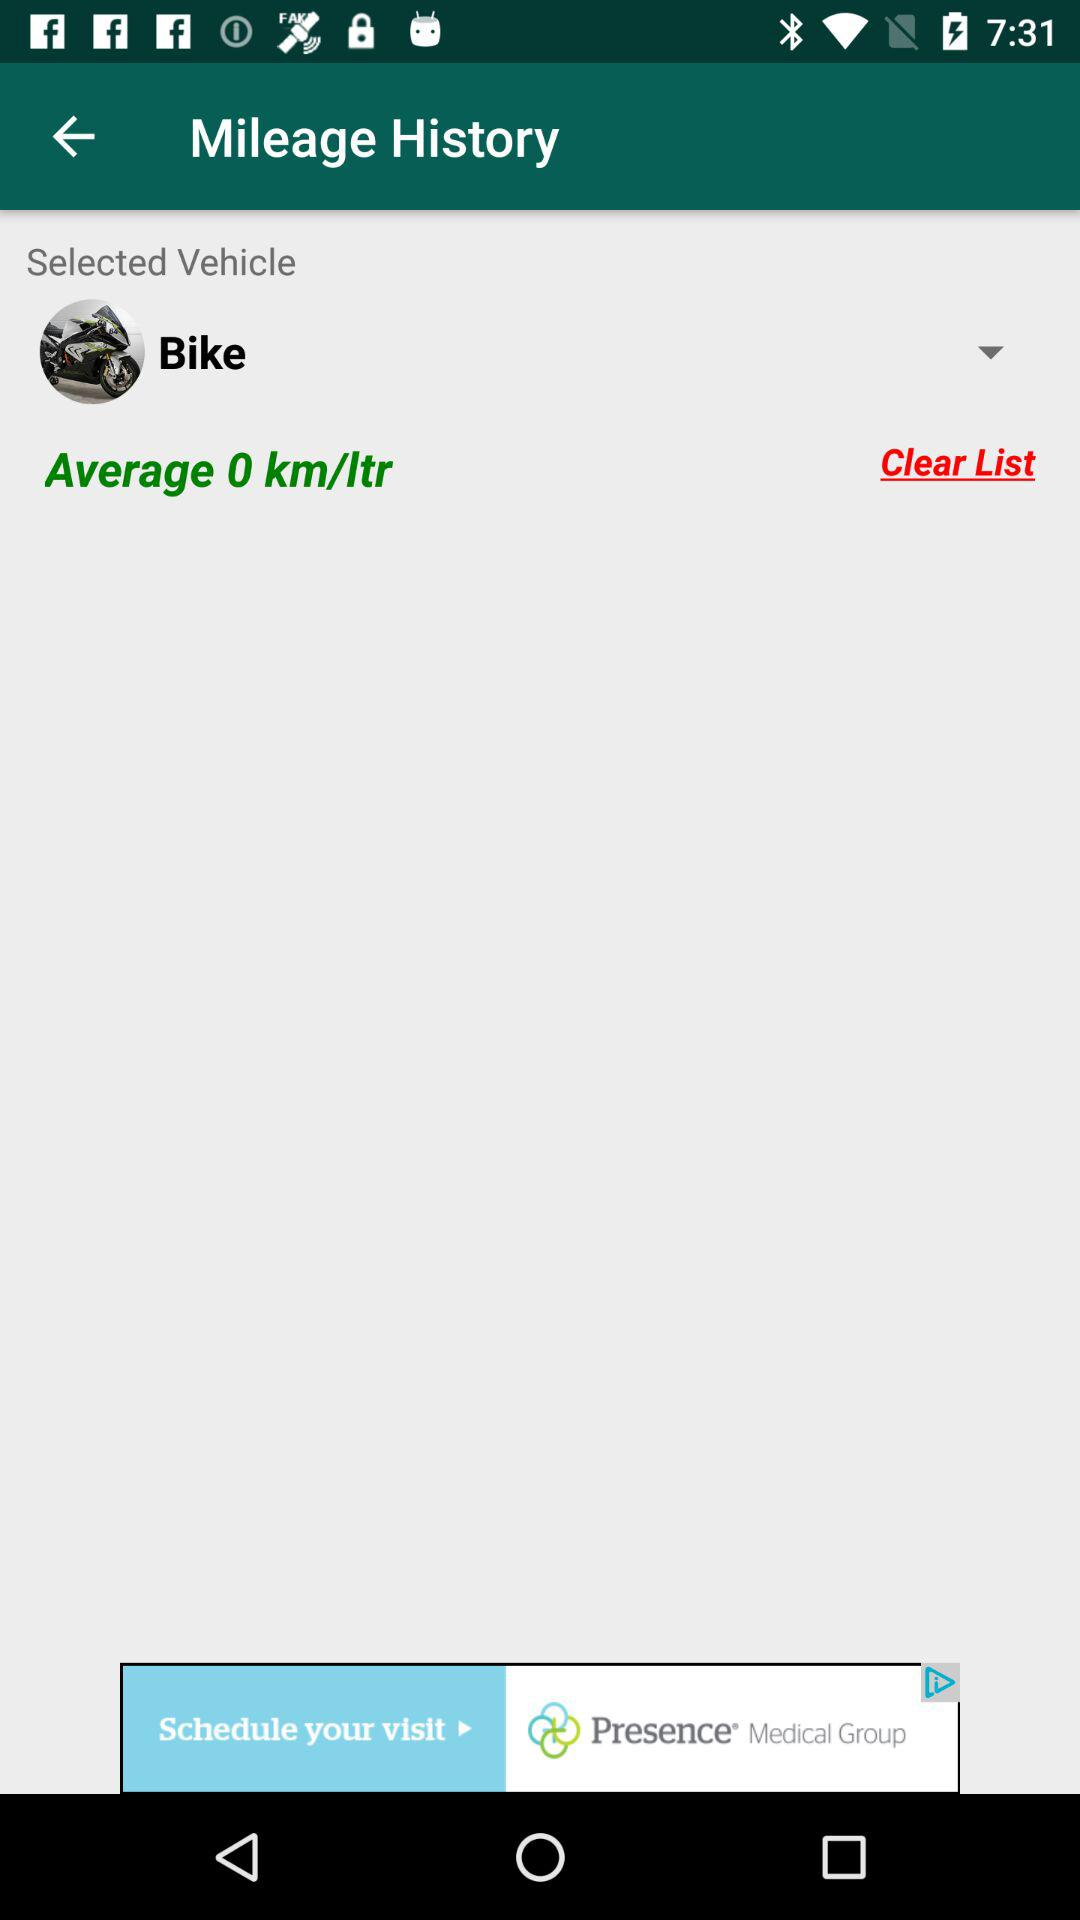What is the average? The average is 0 km/ltr. 